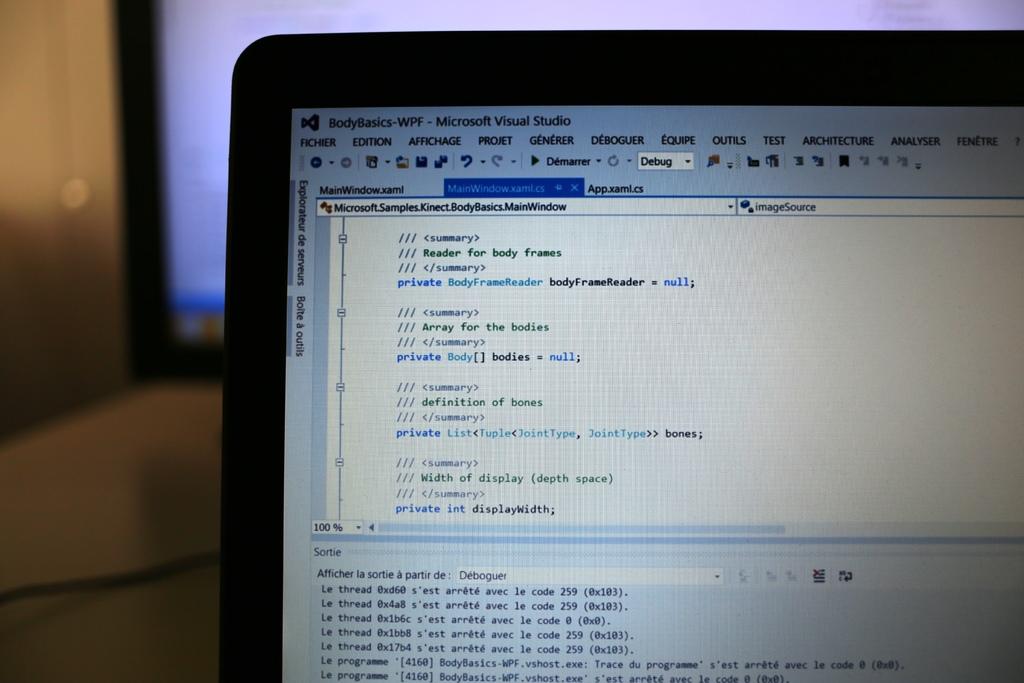What program is this person working in?
Your answer should be compact. Microsoft visual studio. What are the first two words are displayed at the very bottom of the screen?
Give a very brief answer. Le programme. 